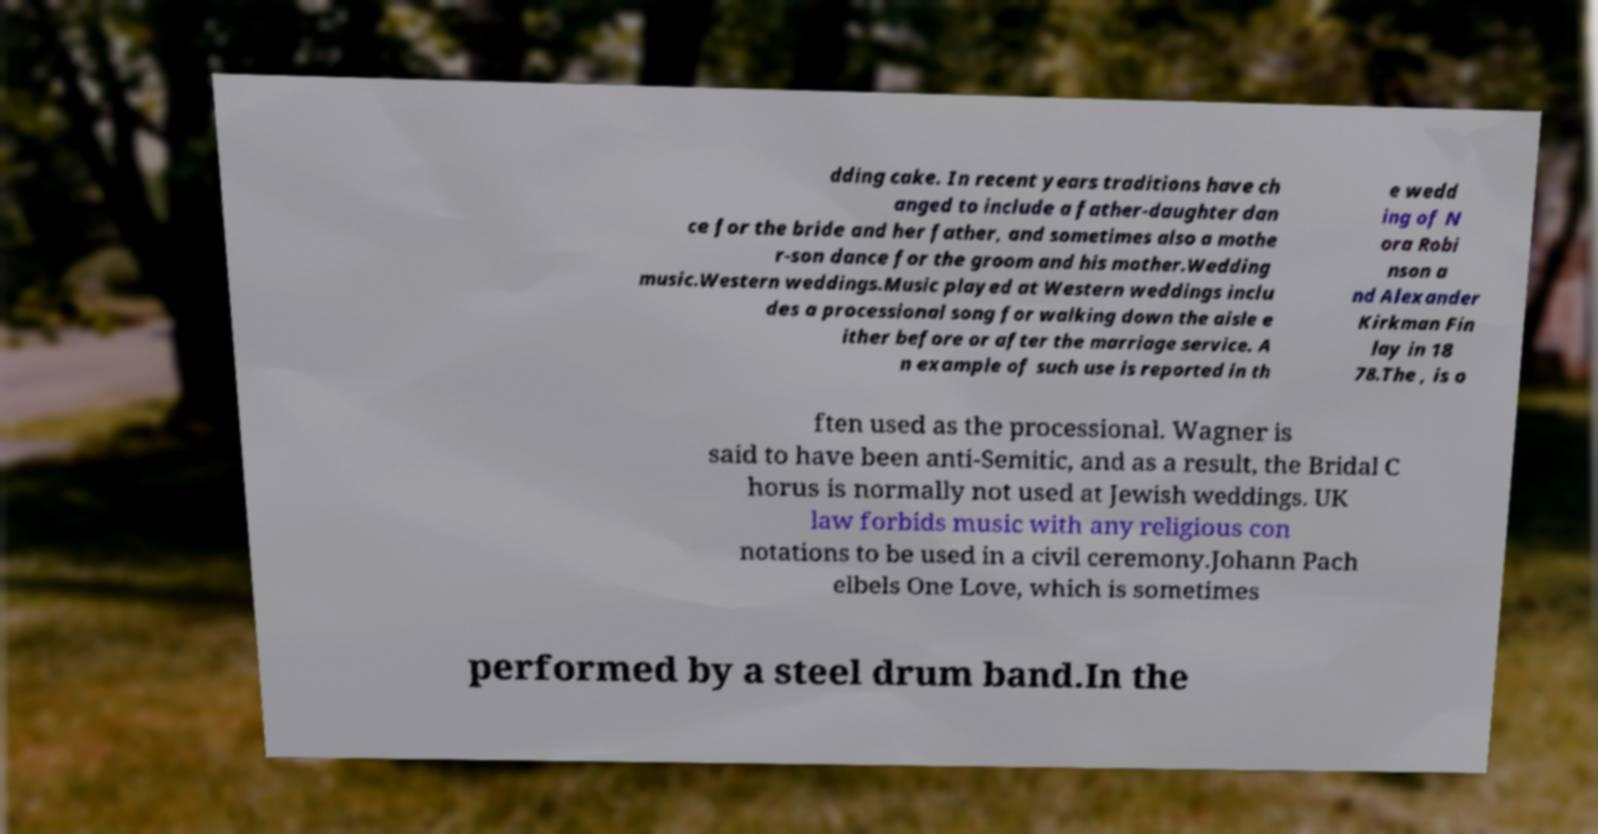Please identify and transcribe the text found in this image. dding cake. In recent years traditions have ch anged to include a father-daughter dan ce for the bride and her father, and sometimes also a mothe r-son dance for the groom and his mother.Wedding music.Western weddings.Music played at Western weddings inclu des a processional song for walking down the aisle e ither before or after the marriage service. A n example of such use is reported in th e wedd ing of N ora Robi nson a nd Alexander Kirkman Fin lay in 18 78.The , is o ften used as the processional. Wagner is said to have been anti-Semitic, and as a result, the Bridal C horus is normally not used at Jewish weddings. UK law forbids music with any religious con notations to be used in a civil ceremony.Johann Pach elbels One Love, which is sometimes performed by a steel drum band.In the 